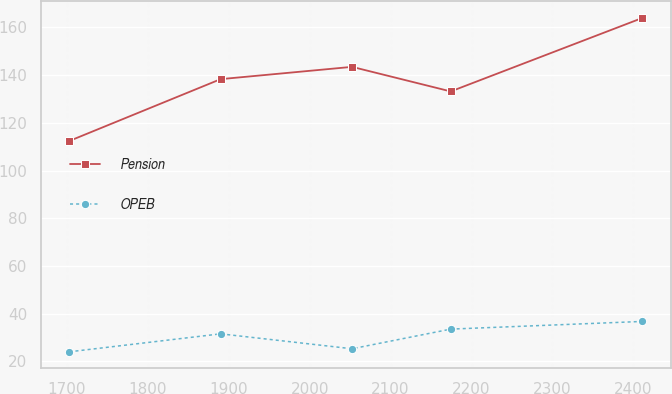<chart> <loc_0><loc_0><loc_500><loc_500><line_chart><ecel><fcel>Pension<fcel>OPEB<nl><fcel>1703.16<fcel>112.39<fcel>24.02<nl><fcel>1890.06<fcel>138.29<fcel>31.55<nl><fcel>2052.42<fcel>143.44<fcel>25.29<nl><fcel>2174.34<fcel>133.14<fcel>33.53<nl><fcel>2410.48<fcel>163.86<fcel>36.74<nl></chart> 